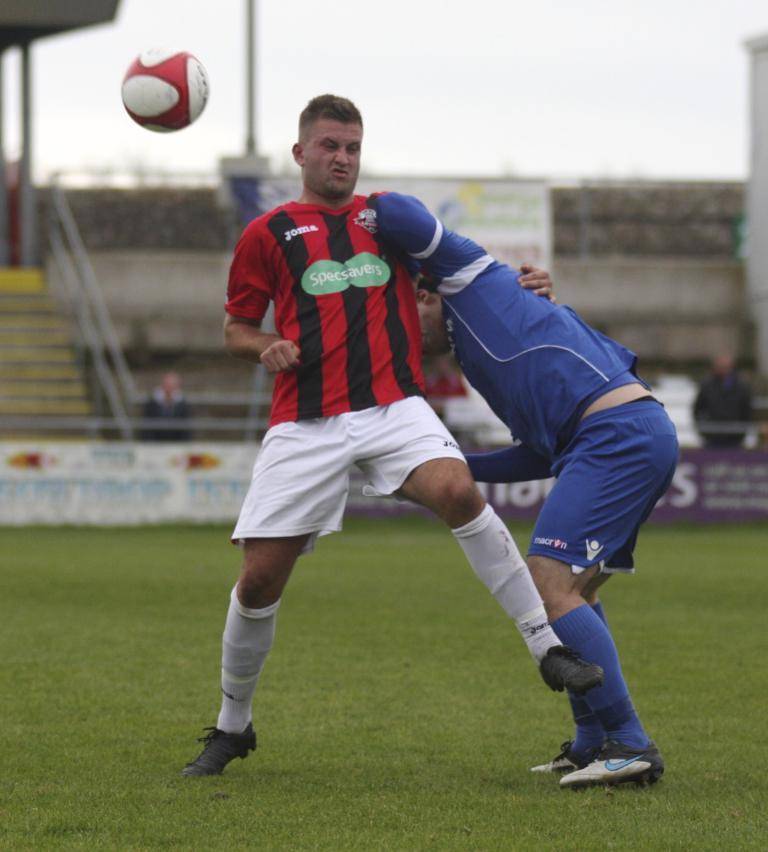What are the men in the image doing? The men in the image are standing on the ground. What is happening in the air in the image? There is a ball in the air. What type of structures can be seen in the image? Advertisement boards, a staircase, railings, and poles are visible in the image. What part of the natural environment is visible in the image? The sky is visible in the image. What language is being spoken by the men in the image? There is no indication of any language being spoken in the image, as it only shows men standing on the ground and a ball in the air. What type of cup is being used by the men in the image? There is no cup present in the image. 